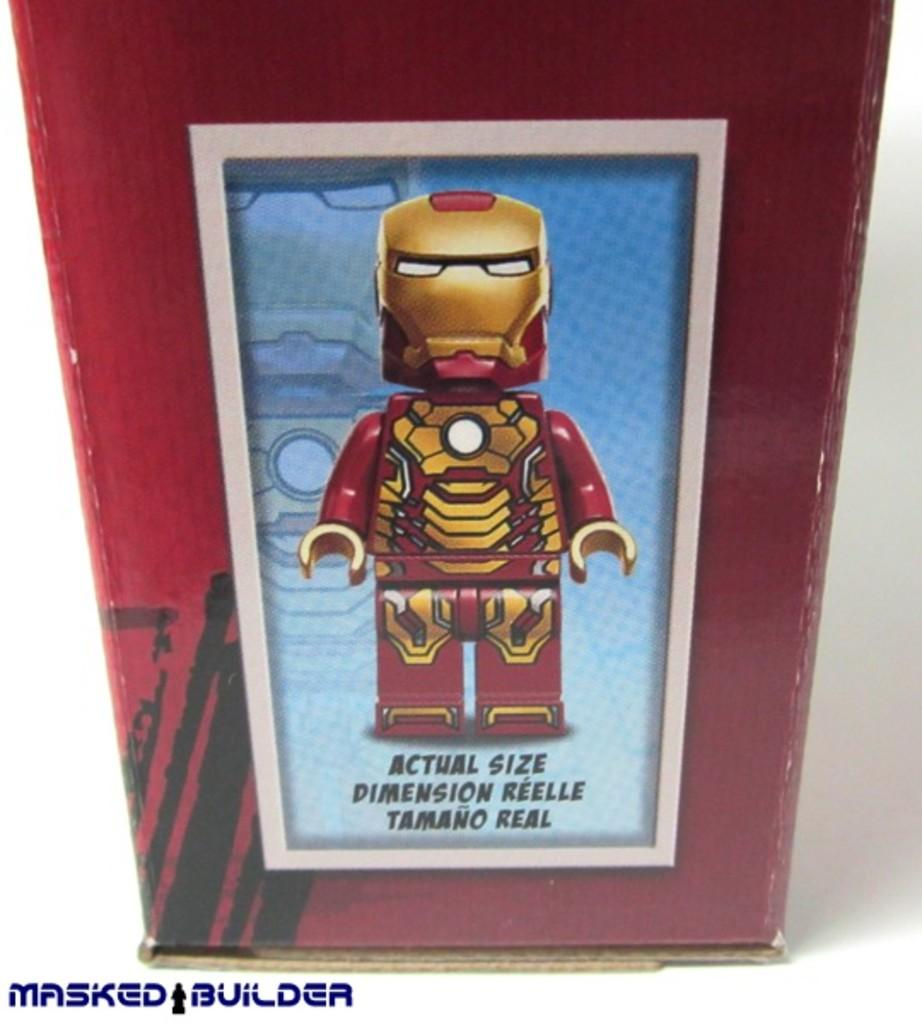<image>
Summarize the visual content of the image. An Actual Size lego is shown in the box 